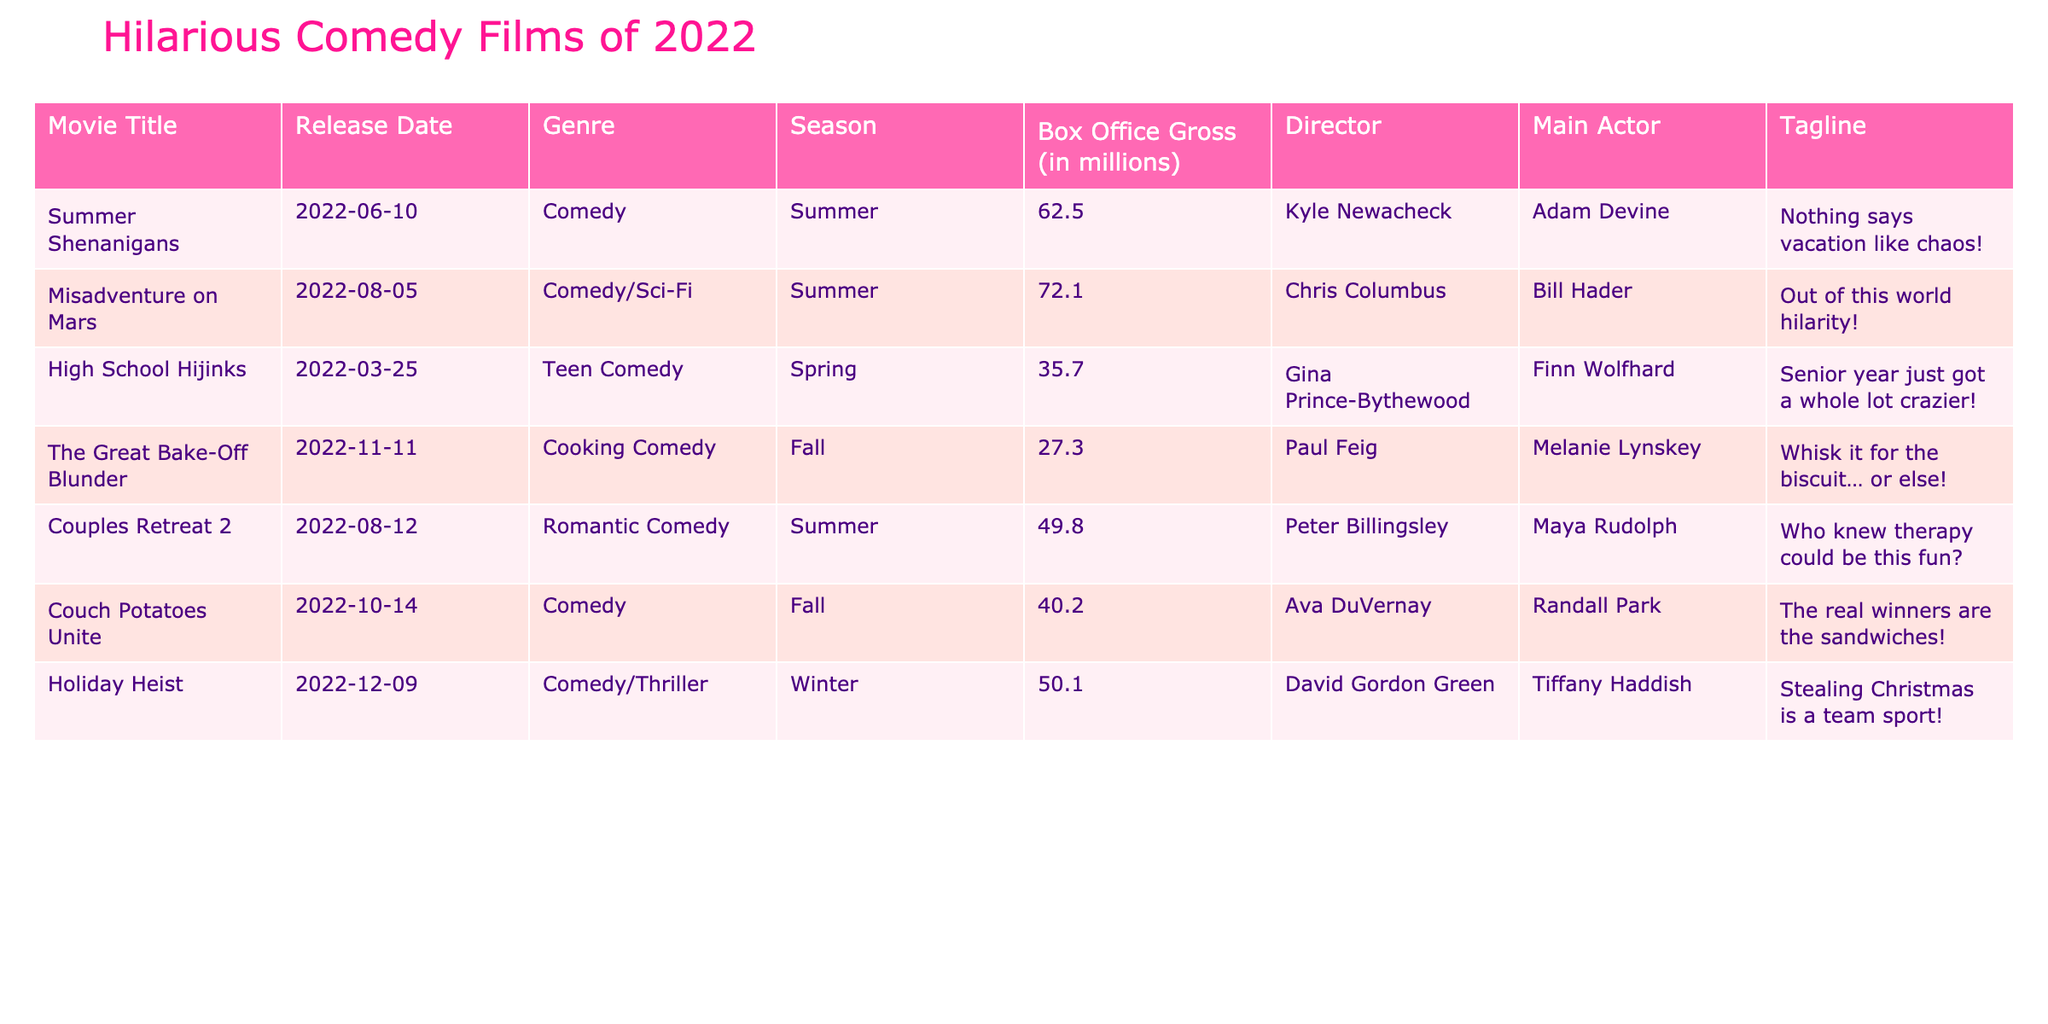What is the highest box office gross among the comedy films listed? The values for box office gross are 62.5, 72.1, 35.7, 27.3, 49.8, 40.2, and 50.1 million. The highest value is 72.1 million from "Misadventure on Mars".
Answer: 72.1 million Which comedy film had the lowest box office gross? The values for box office gross are listed, with "The Great Bake-Off Blunder" having the lowest at 27.3 million.
Answer: 27.3 million How many comedies were released in the summer season? "Summer Shenanigans," "Misadventure on Mars," and "Couples Retreat 2" are all marked as summer releases, totaling three films.
Answer: 3 What is the average box office gross of the comedy films released in the fall season? The fall films are "The Great Bake-Off Blunder" (27.3 million), "Couch Potatoes Unite" (40.2 million). Their sum is 67.5 million. Dividing by 2 gives an average of 33.75 million.
Answer: 33.75 million Which director had a film with a box office gross greater than 50 million? The films "Summer Shenanigans" (62.5 million) and "Misadventure on Mars" (72.1 million) are directed by Kyle Newacheck and Chris Columbus respectively, both over 50 million.
Answer: Yes How much more did "Misadventure on Mars" earn compared to "High School Hijinks"? "Misadventure on Mars" earned 72.1 million, while "High School Hijinks" earned 35.7 million. The difference is 72.1 - 35.7 = 36.4 million.
Answer: 36.4 million Is there any film that had more than 50 million in box office gross in the winter? Analyzing the data, "Holiday Heist" had 50.1 million gross, so it meets the criteria of being over 50 million.
Answer: Yes Which season had the highest overall box office earnings from the films listed? The summer films have box office grosses of 62.5, 72.1, and 49.8 million, totaling 184.4 million. The other seasons combined do not exceed this total.
Answer: Summer What tagline was used for "Couch Potatoes Unite"? The tagline for "Couch Potatoes Unite" is "The real winners are the sandwiches!" which is clearly referenced in the table.
Answer: "The real winners are the sandwiches!" How many genres are represented in the comedy films listed? The genres include "Comedy," "Comedy/Sci-Fi," "Teen Comedy," "Cooking Comedy," "Romantic Comedy," and "Comedy/Thriller," totaling six unique genres.
Answer: 6 